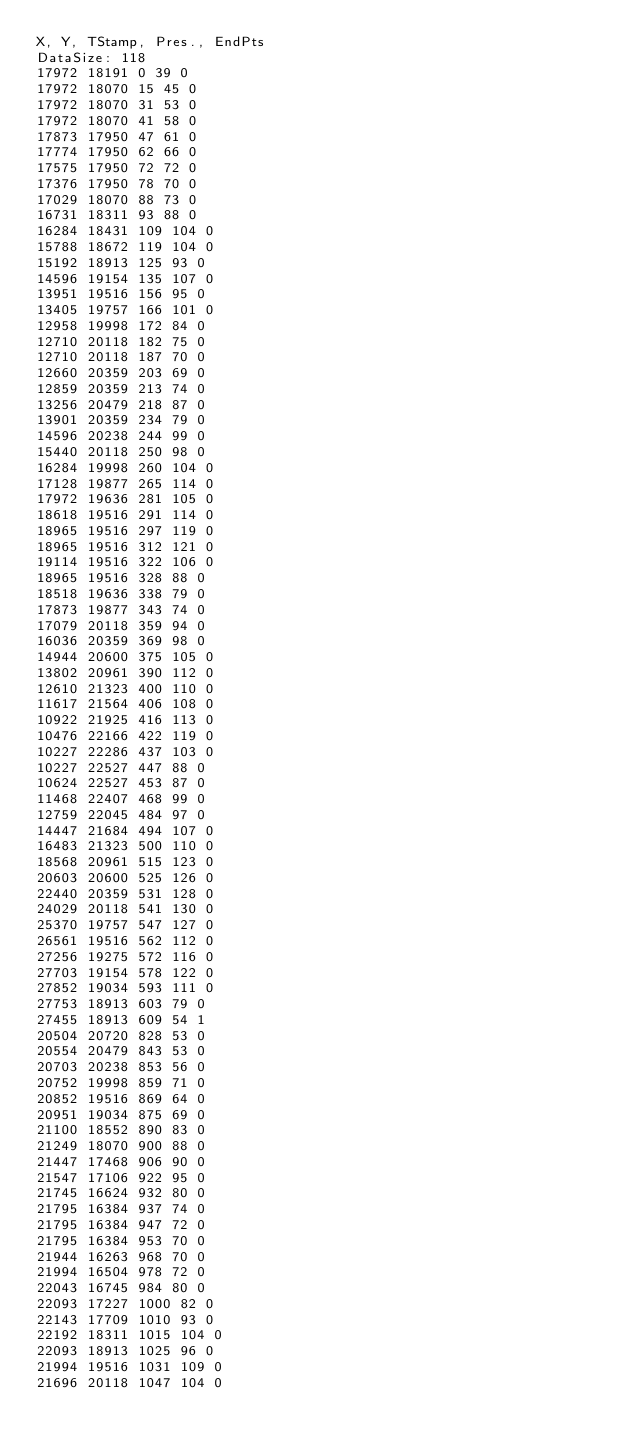Convert code to text. <code><loc_0><loc_0><loc_500><loc_500><_SML_>X, Y, TStamp, Pres., EndPts
DataSize: 118
17972 18191 0 39 0
17972 18070 15 45 0
17972 18070 31 53 0
17972 18070 41 58 0
17873 17950 47 61 0
17774 17950 62 66 0
17575 17950 72 72 0
17376 17950 78 70 0
17029 18070 88 73 0
16731 18311 93 88 0
16284 18431 109 104 0
15788 18672 119 104 0
15192 18913 125 93 0
14596 19154 135 107 0
13951 19516 156 95 0
13405 19757 166 101 0
12958 19998 172 84 0
12710 20118 182 75 0
12710 20118 187 70 0
12660 20359 203 69 0
12859 20359 213 74 0
13256 20479 218 87 0
13901 20359 234 79 0
14596 20238 244 99 0
15440 20118 250 98 0
16284 19998 260 104 0
17128 19877 265 114 0
17972 19636 281 105 0
18618 19516 291 114 0
18965 19516 297 119 0
18965 19516 312 121 0
19114 19516 322 106 0
18965 19516 328 88 0
18518 19636 338 79 0
17873 19877 343 74 0
17079 20118 359 94 0
16036 20359 369 98 0
14944 20600 375 105 0
13802 20961 390 112 0
12610 21323 400 110 0
11617 21564 406 108 0
10922 21925 416 113 0
10476 22166 422 119 0
10227 22286 437 103 0
10227 22527 447 88 0
10624 22527 453 87 0
11468 22407 468 99 0
12759 22045 484 97 0
14447 21684 494 107 0
16483 21323 500 110 0
18568 20961 515 123 0
20603 20600 525 126 0
22440 20359 531 128 0
24029 20118 541 130 0
25370 19757 547 127 0
26561 19516 562 112 0
27256 19275 572 116 0
27703 19154 578 122 0
27852 19034 593 111 0
27753 18913 603 79 0
27455 18913 609 54 1
20504 20720 828 53 0
20554 20479 843 53 0
20703 20238 853 56 0
20752 19998 859 71 0
20852 19516 869 64 0
20951 19034 875 69 0
21100 18552 890 83 0
21249 18070 900 88 0
21447 17468 906 90 0
21547 17106 922 95 0
21745 16624 932 80 0
21795 16384 937 74 0
21795 16384 947 72 0
21795 16384 953 70 0
21944 16263 968 70 0
21994 16504 978 72 0
22043 16745 984 80 0
22093 17227 1000 82 0
22143 17709 1010 93 0
22192 18311 1015 104 0
22093 18913 1025 96 0
21994 19516 1031 109 0
21696 20118 1047 104 0</code> 